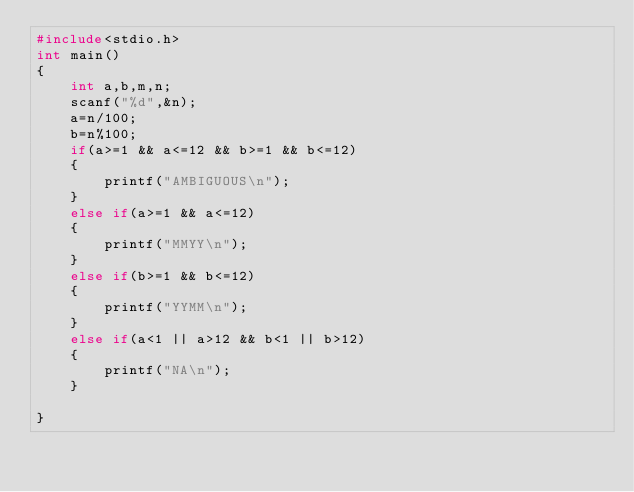Convert code to text. <code><loc_0><loc_0><loc_500><loc_500><_C_>#include<stdio.h>
int main()
{
	int a,b,m,n;
	scanf("%d",&n);
	a=n/100;
	b=n%100;
	if(a>=1 && a<=12 && b>=1 && b<=12)
	{
		printf("AMBIGUOUS\n");
	}
	else if(a>=1 && a<=12)
	{
		printf("MMYY\n");
	}
	else if(b>=1 && b<=12)
	{
		printf("YYMM\n");
	}
	else if(a<1 || a>12 && b<1 || b>12)
	{
		printf("NA\n");
	}
	
}</code> 